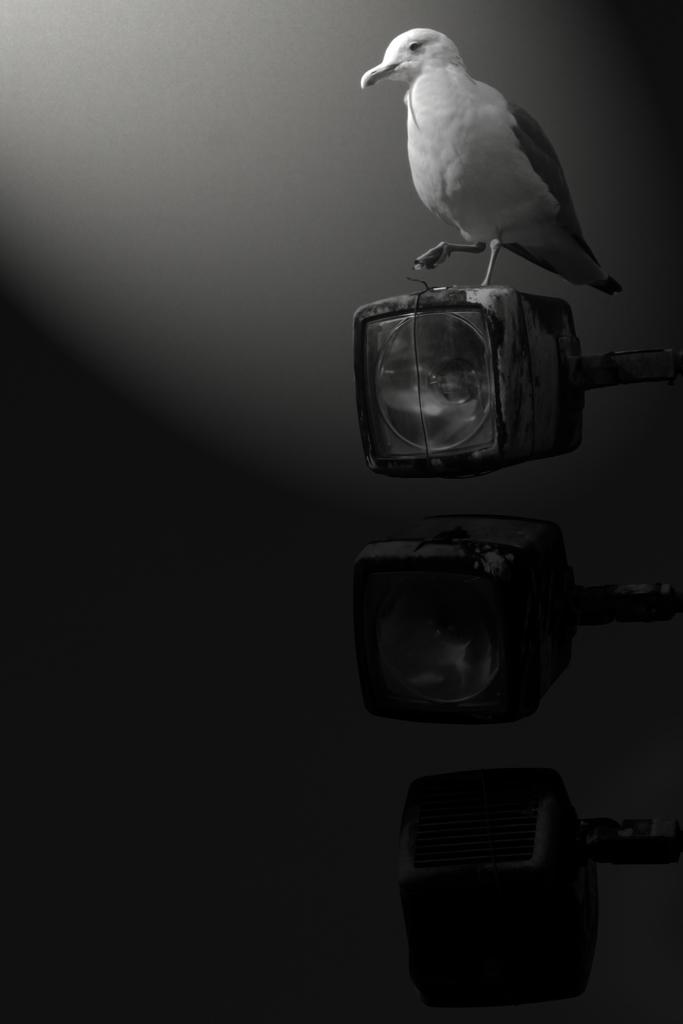What is the color scheme of the image? The image is black and white. What type of animal can be seen in the image? There is a bird in the image. What object is also present in the image? There is a lamp in the image. What type of goat is making a statement in the image? There is no goat present in the image, and no one is making a statement. 